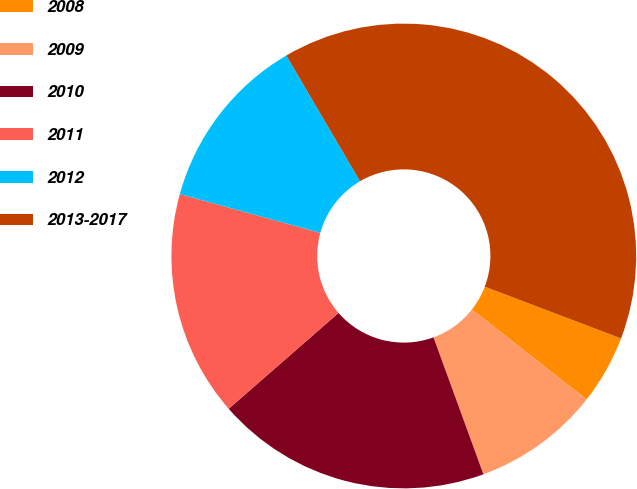Convert chart to OTSL. <chart><loc_0><loc_0><loc_500><loc_500><pie_chart><fcel>2008<fcel>2009<fcel>2010<fcel>2011<fcel>2012<fcel>2013-2017<nl><fcel>4.82%<fcel>8.84%<fcel>19.15%<fcel>15.71%<fcel>12.27%<fcel>39.21%<nl></chart> 